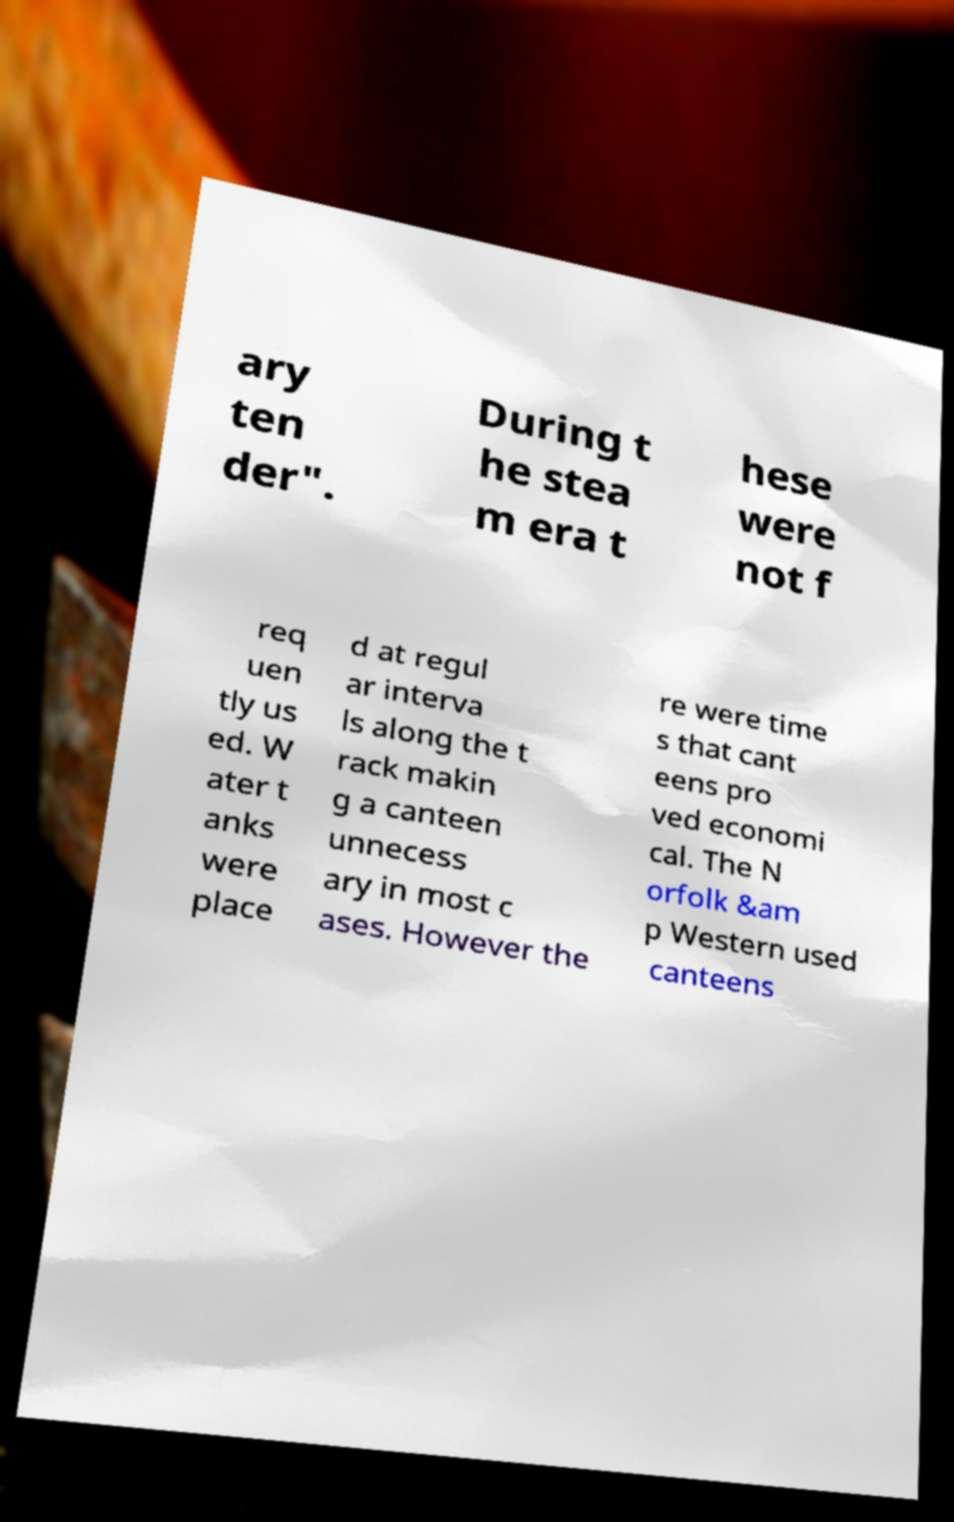Could you assist in decoding the text presented in this image and type it out clearly? ary ten der". During t he stea m era t hese were not f req uen tly us ed. W ater t anks were place d at regul ar interva ls along the t rack makin g a canteen unnecess ary in most c ases. However the re were time s that cant eens pro ved economi cal. The N orfolk &am p Western used canteens 